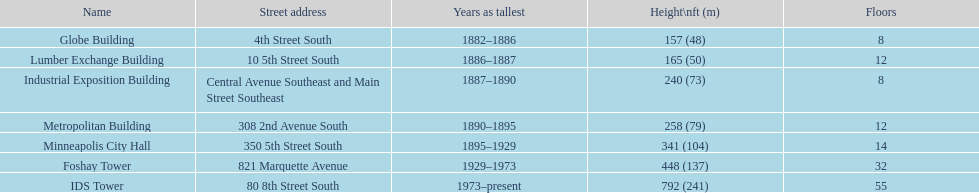Which structure possesses an equal amount of levels as the lumber exchange building? Metropolitan Building. Write the full table. {'header': ['Name', 'Street address', 'Years as tallest', 'Height\\nft (m)', 'Floors'], 'rows': [['Globe Building', '4th Street South', '1882–1886', '157 (48)', '8'], ['Lumber Exchange Building', '10 5th Street South', '1886–1887', '165 (50)', '12'], ['Industrial Exposition Building', 'Central Avenue Southeast and Main Street Southeast', '1887–1890', '240 (73)', '8'], ['Metropolitan Building', '308 2nd Avenue South', '1890–1895', '258 (79)', '12'], ['Minneapolis City Hall', '350 5th Street South', '1895–1929', '341 (104)', '14'], ['Foshay Tower', '821 Marquette Avenue', '1929–1973', '448 (137)', '32'], ['IDS Tower', '80 8th Street South', '1973–present', '792 (241)', '55']]} 